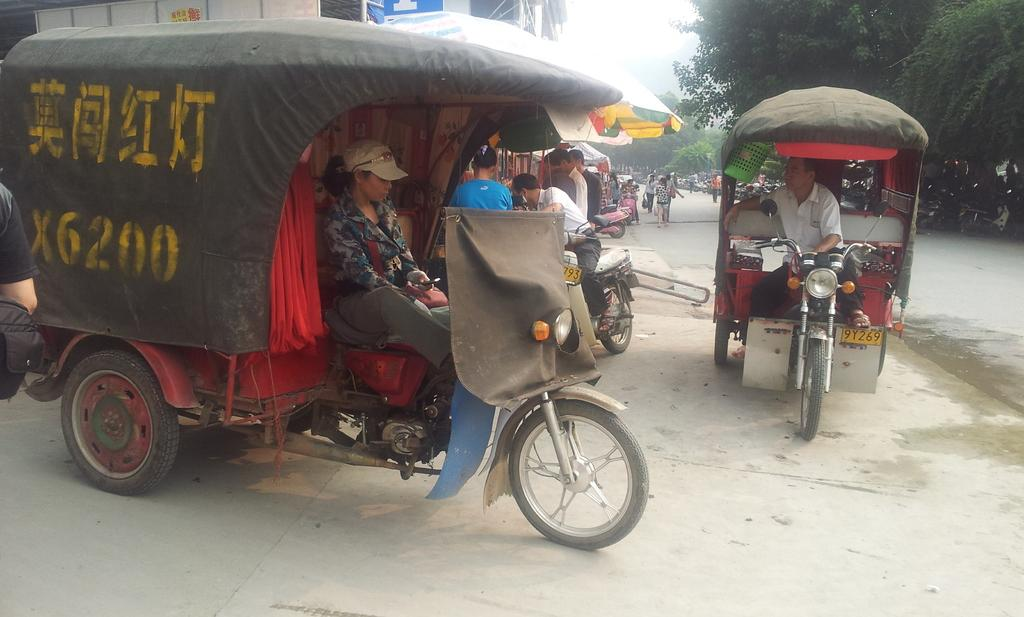How many people are in the group visible in the image? There is a group of people in the image, but the exact number cannot be determined from the provided facts. What type of vehicles can be seen on the road in the image? Vehicles are present on the road in the image, but their specific types cannot be determined from the provided facts. What type of vegetation is present in the image? Trees are present in the image. What are the people in the group holding in the image? Umbrellas are visible in the image, but it is not clear if the people in the group are holding them. What other objects can be seen in the image besides the group of people and vehicles? There are other objects in the image, but their specific types cannot be determined from the provided facts. What is visible in the background of the image? The sky is visible in the background of the image. How many snakes are slithering on the road in the image? There are no snakes present in the image; only vehicles and a group of people can be seen on the road. 